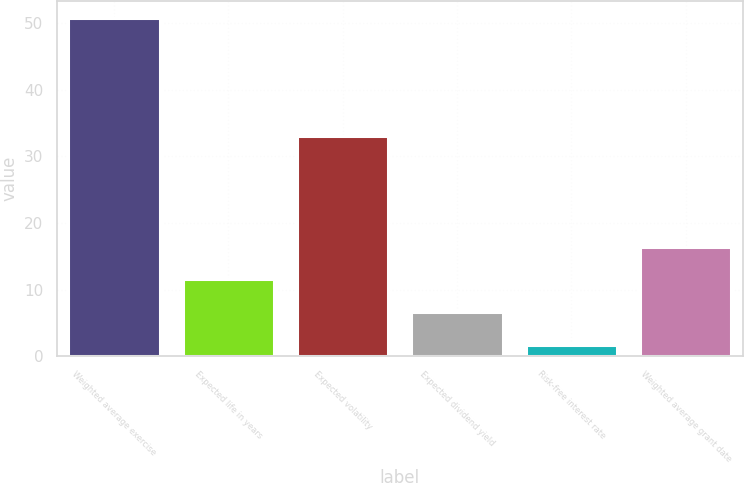Convert chart to OTSL. <chart><loc_0><loc_0><loc_500><loc_500><bar_chart><fcel>Weighted average exercise<fcel>Expected life in years<fcel>Expected volatility<fcel>Expected dividend yield<fcel>Risk-free interest rate<fcel>Weighted average grant date<nl><fcel>50.85<fcel>11.54<fcel>33<fcel>6.62<fcel>1.7<fcel>16.45<nl></chart> 